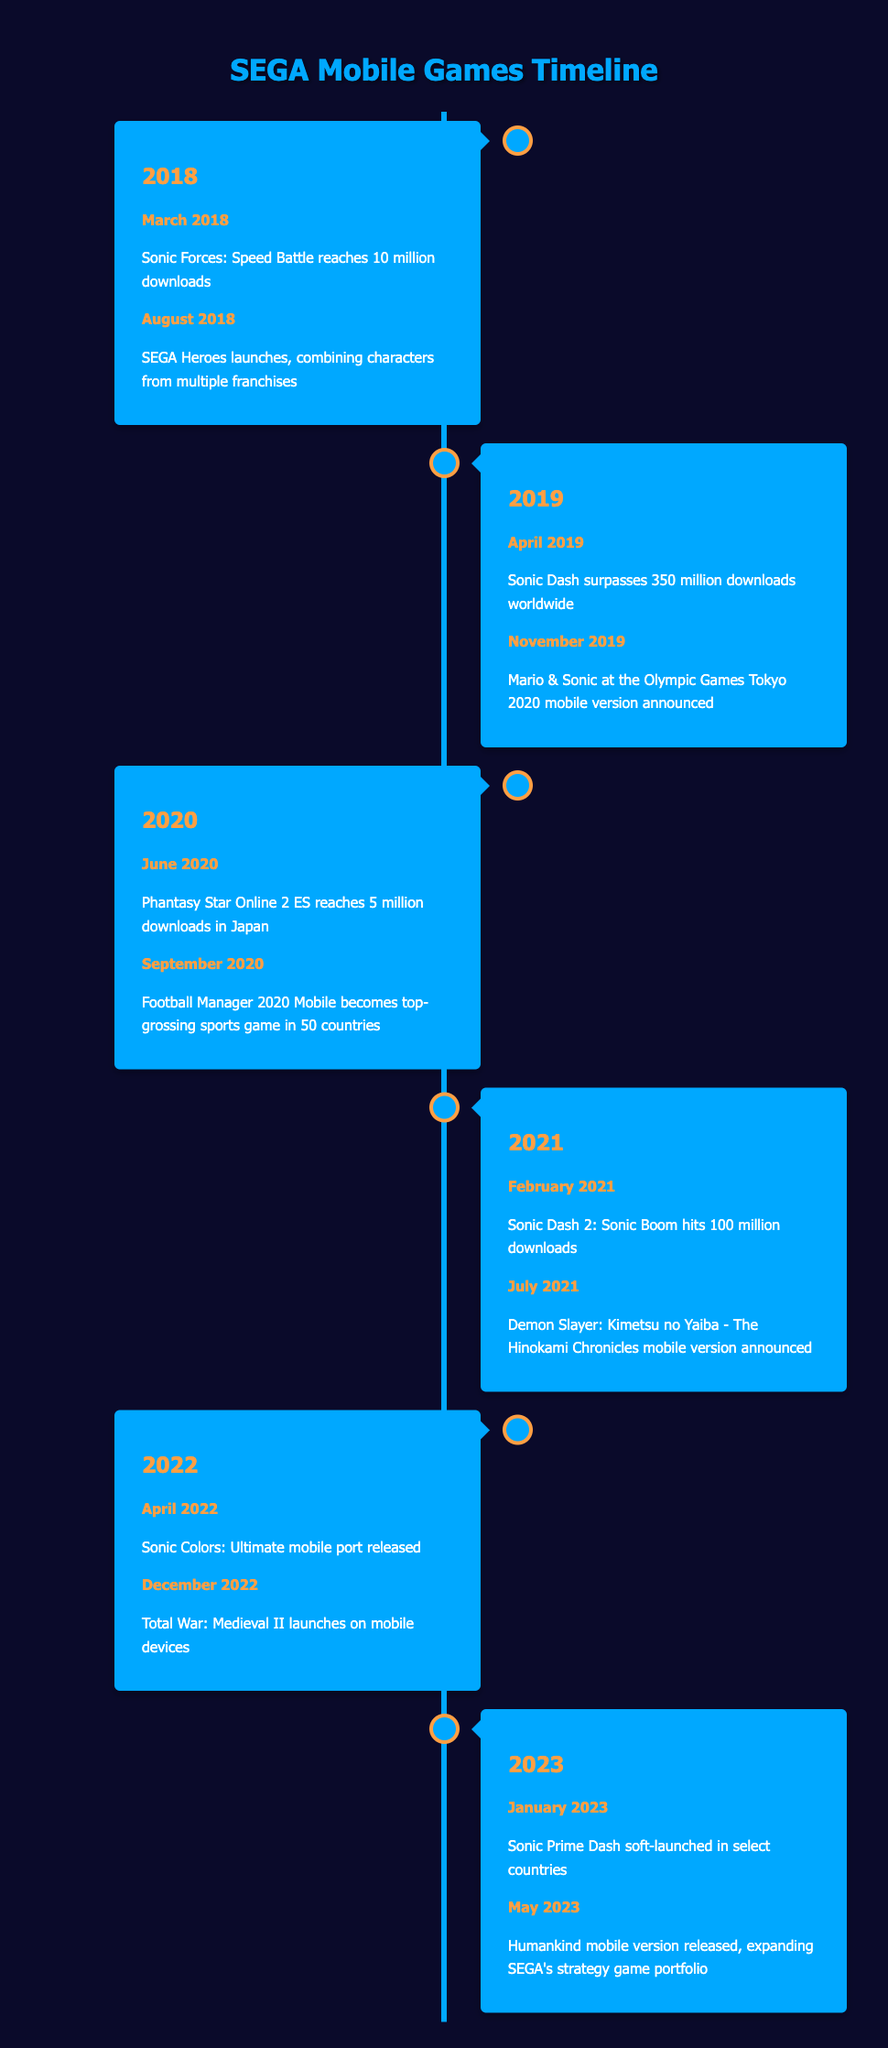What event occurred in March 2018? The table indicates that in March 2018, Sonic Forces: Speed Battle reached 10 million downloads, which is explicitly stated in the events for that year.
Answer: Sonic Forces: Speed Battle reaches 10 million downloads Which SEGA mobile game surpassed 350 million downloads and when? According to the table, Sonic Dash surpassed 350 million downloads in April 2019, as mentioned under the events for that year.
Answer: Sonic Dash, April 2019 Were there any game launches announced in 2021? The table shows that there was indeed an announcement for the mobile version of Demon Slayer: Kimetsu no Yaiba - The Hinokami Chronicles in July 2021, confirming that such game launches took place that year.
Answer: Yes How many major SEGA mobile game releases or announcements took place in 2022? In 2022, there were two major events listed: the release of Sonic Colors: Ultimate mobile port in April and the launch of Total War: Medieval II in December, which totals to two releases/announcements that year.
Answer: 2 What was the gap in months between Sonic Prime Dash soft-launch and the release of Humankind's mobile version? Sonic Prime Dash soft-launched in January 2023 and Humankind's mobile version was released in May 2023. This means there was a gap of four months (February, March, April, May).
Answer: 4 months In which year did SEGA Heroes launch? The table indicates that SEGA Heroes launched in August 2018, which is directly stated in the events for that particular year.
Answer: 2018 Did any SEGA mobile game reach a significant download milestone in 2020? Yes, the table shows that Phantasy Star Online 2 ES reached 5 million downloads in June 2020, indicating a noteworthy milestone for that year.
Answer: Yes What is the total number of mobile events recorded from 2018 to 2023? By summing up the events listed per year from 2018 (2) to 2023 (2), we find there are a total of 12 events recorded over these years (2 + 2 + 2 + 2 + 2 + 2 = 12).
Answer: 12 